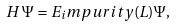<formula> <loc_0><loc_0><loc_500><loc_500>H \, \Psi = E _ { i } m p u r i t y ( L ) \Psi ,</formula> 